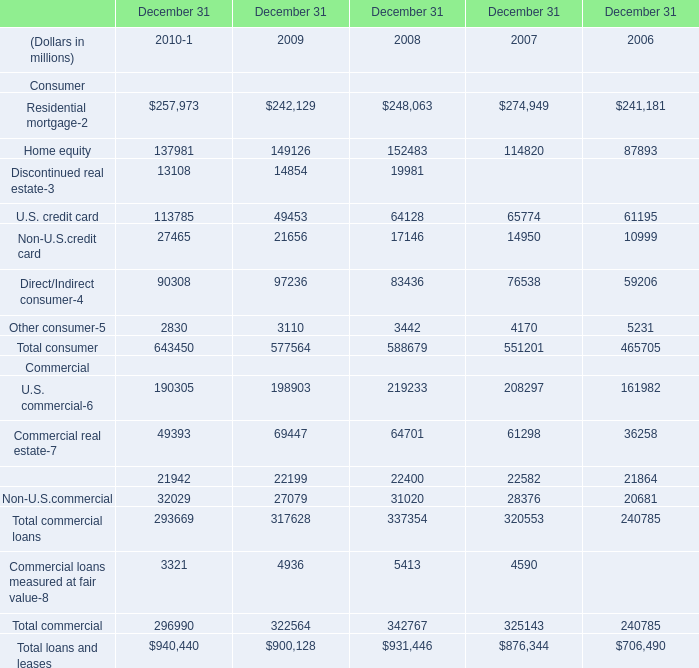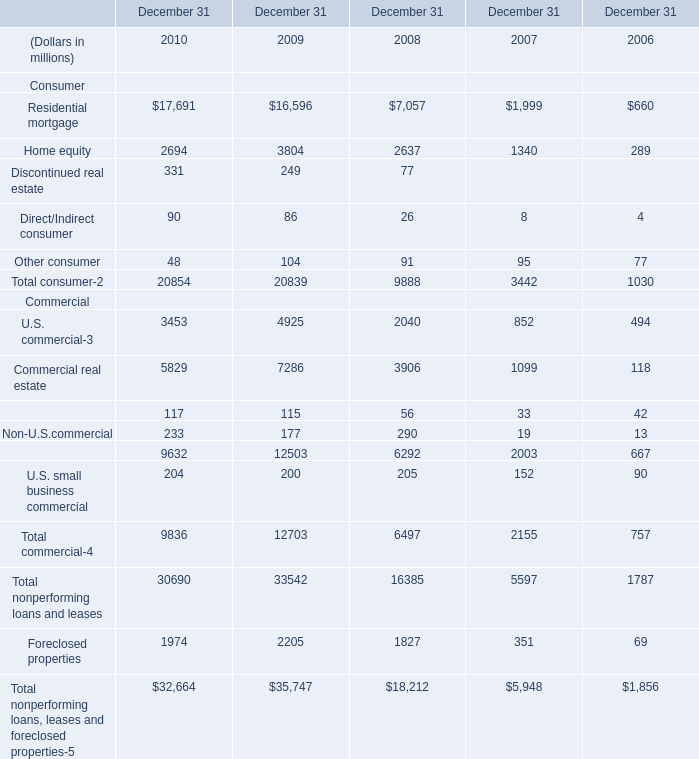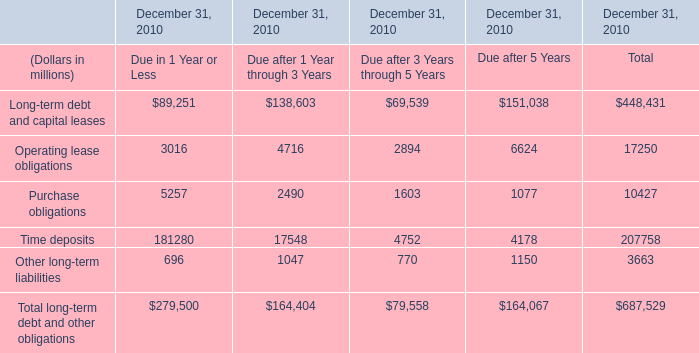What is the sum of Home equity of December 31 2010, U.S. credit card of December 31 2007, and Commercial lease financing Commercial of December 31 2008 ? 
Computations: ((2694.0 + 65774.0) + 22400.0)
Answer: 90868.0. 